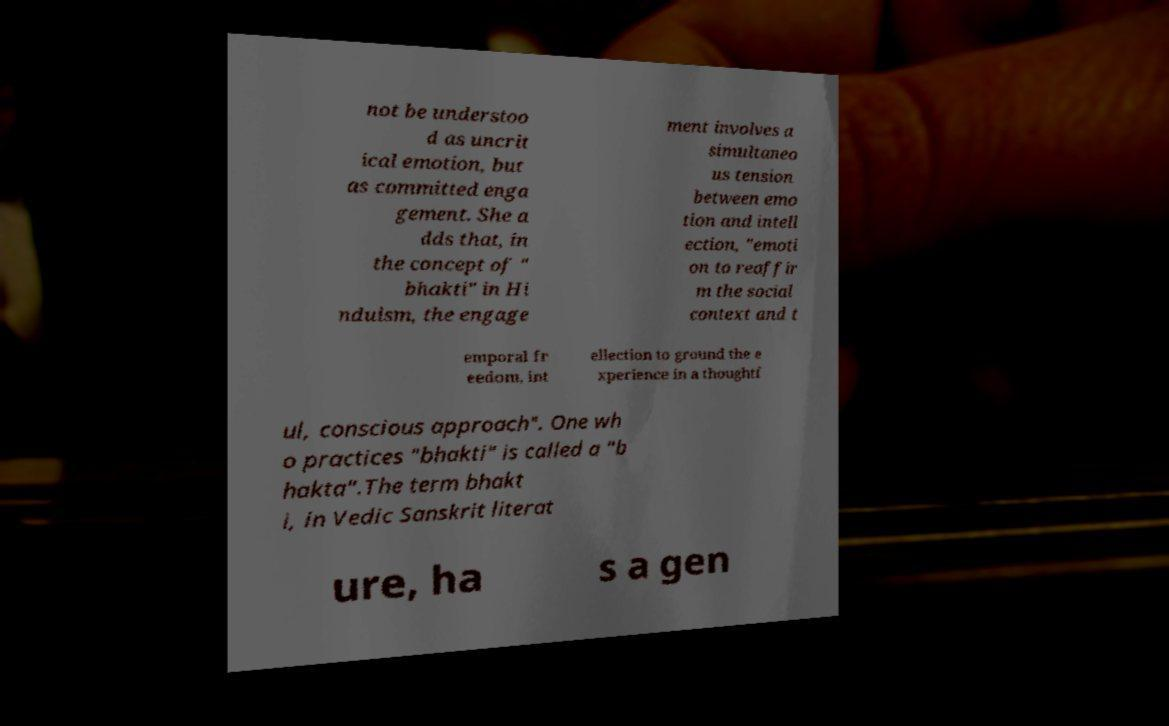For documentation purposes, I need the text within this image transcribed. Could you provide that? not be understoo d as uncrit ical emotion, but as committed enga gement. She a dds that, in the concept of " bhakti" in Hi nduism, the engage ment involves a simultaneo us tension between emo tion and intell ection, "emoti on to reaffir m the social context and t emporal fr eedom, int ellection to ground the e xperience in a thoughtf ul, conscious approach". One wh o practices "bhakti" is called a "b hakta".The term bhakt i, in Vedic Sanskrit literat ure, ha s a gen 